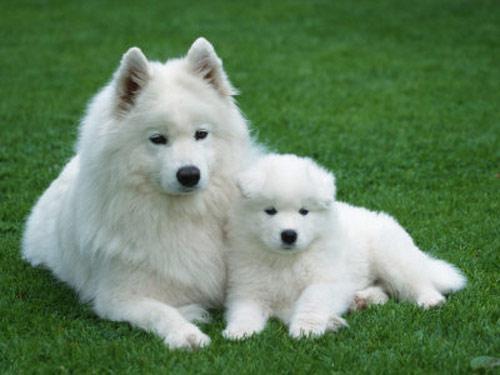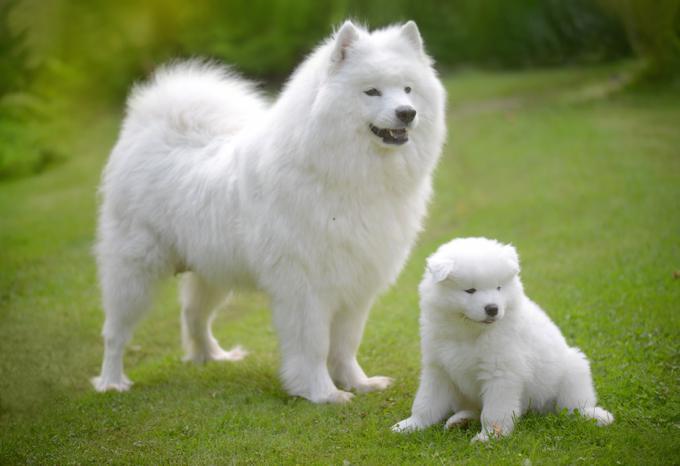The first image is the image on the left, the second image is the image on the right. Evaluate the accuracy of this statement regarding the images: "There is an adult dog and a puppy in the left image.". Is it true? Answer yes or no. Yes. 